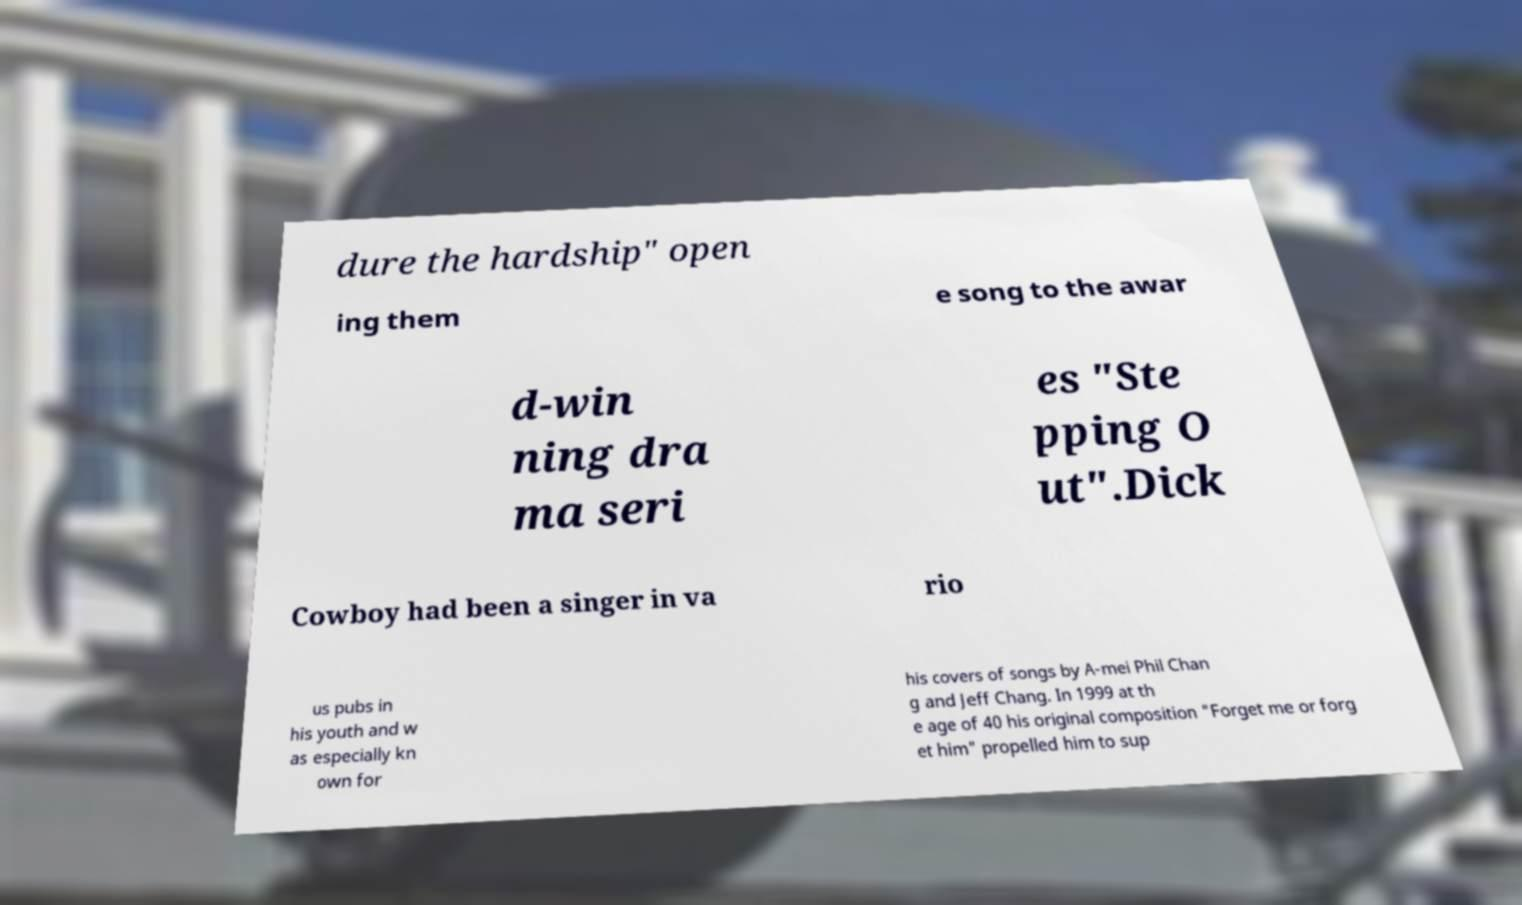I need the written content from this picture converted into text. Can you do that? dure the hardship" open ing them e song to the awar d-win ning dra ma seri es "Ste pping O ut".Dick Cowboy had been a singer in va rio us pubs in his youth and w as especially kn own for his covers of songs by A-mei Phil Chan g and Jeff Chang. In 1999 at th e age of 40 his original composition "Forget me or forg et him" propelled him to sup 